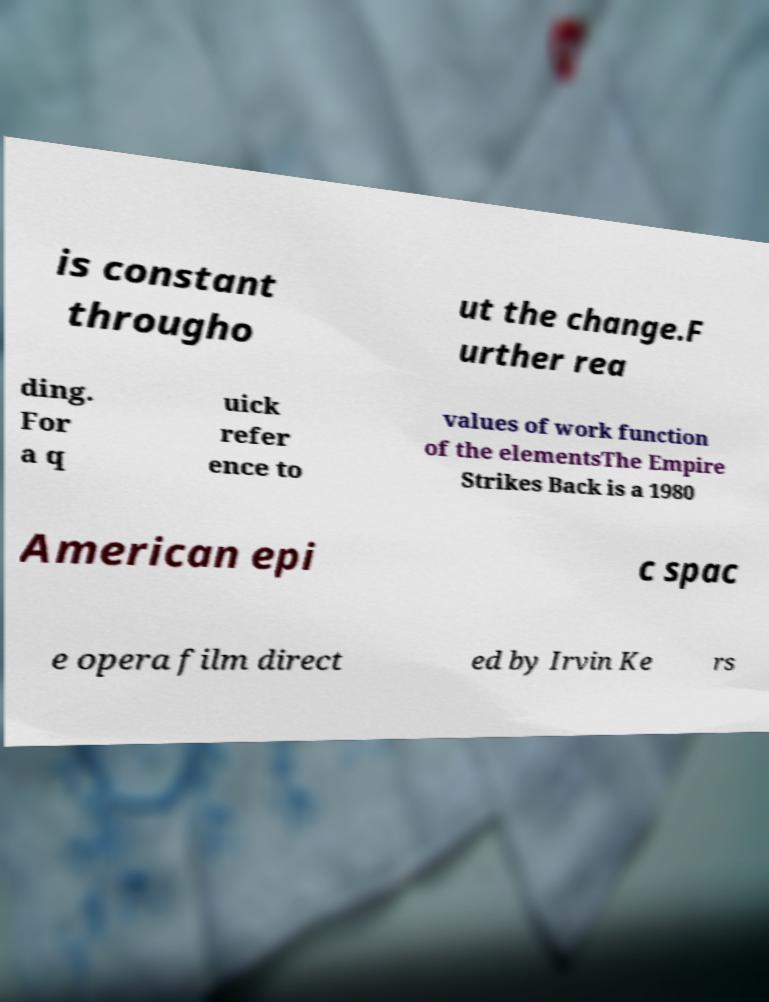Could you extract and type out the text from this image? is constant througho ut the change.F urther rea ding. For a q uick refer ence to values of work function of the elementsThe Empire Strikes Back is a 1980 American epi c spac e opera film direct ed by Irvin Ke rs 